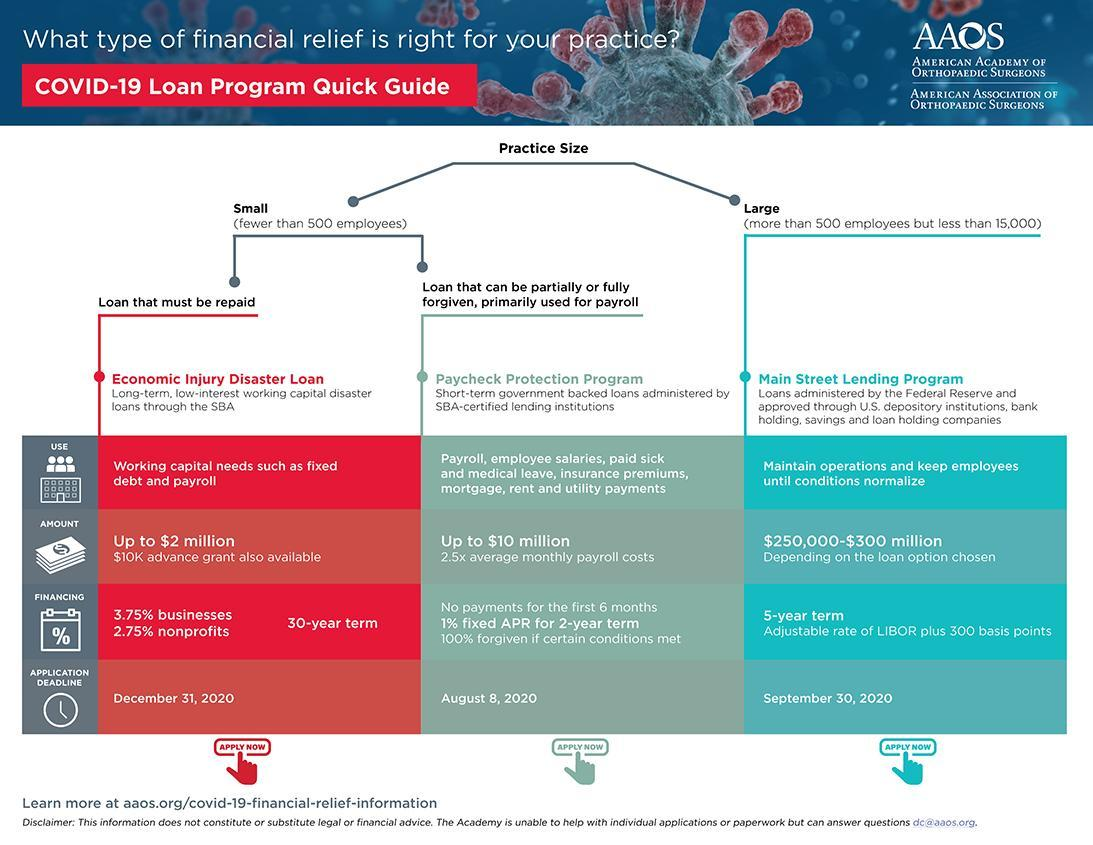What is the tenure of Main Street Leading Program loan?
Answer the question with a short phrase. 5-year What is the maximum Economic Injury Disaster Loan amount? $2 million What is the deadline for Paycheck Protection Program loan application? August 8, 2020 What is the maximum Paycheck Protection Program loan amount? $10 million What is the tenure of Economic Injury Disaster Loan? 30-year term What is the deadline for Main Street Leading Program loan application? September 30, 2020 